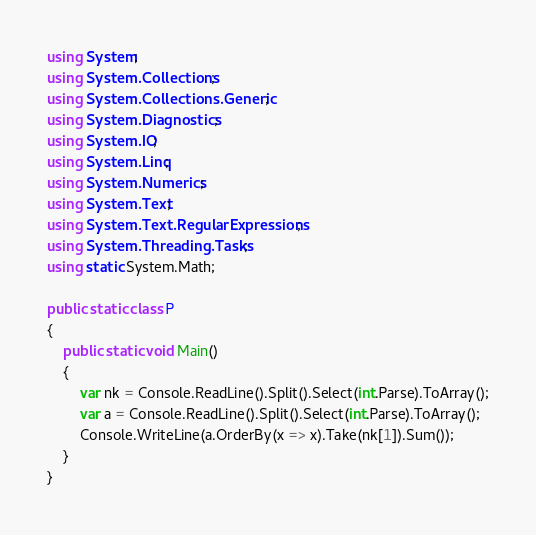<code> <loc_0><loc_0><loc_500><loc_500><_C#_>using System;
using System.Collections;
using System.Collections.Generic;
using System.Diagnostics;
using System.IO;
using System.Linq;
using System.Numerics;
using System.Text;
using System.Text.RegularExpressions;
using System.Threading.Tasks;
using static System.Math;

public static class P
{
    public static void Main()
    {
        var nk = Console.ReadLine().Split().Select(int.Parse).ToArray();
        var a = Console.ReadLine().Split().Select(int.Parse).ToArray();
        Console.WriteLine(a.OrderBy(x => x).Take(nk[1]).Sum());
    }
}
</code> 